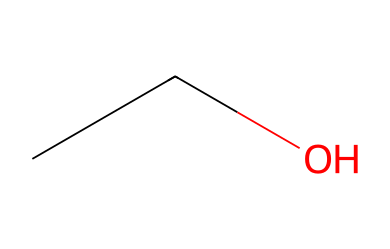How many carbon atoms are present in this molecule? The given SMILES representation "CCO" indicates two carbon atoms (C) since each "C" in the SMILES notation represents a carbon atom.
Answer: 2 What type of functional group does ethanol contain? The structure includes a hydroxyl group (-OH), which is characteristic of alcohols. In the given SMILES, the "O" following the two "C" indicates the presence of this functional group.
Answer: alcohol How many hydrogen atoms are associated with this molecule? In the SMILES "CCO", there are two carbon atoms each connected to a hydroxyl group, leading to a total of six hydrogen atoms when considering the valences of carbon and oxygen. Ethanol follows the formula C2H6O.
Answer: 6 Is this chemical polar or nonpolar? Ethanol contains a hydroxyl (-OH) group, making it polar due to the difference in electronegativity between oxygen and hydrogen, which creates a dipole moment.
Answer: polar What is the molecular weight of ethanol? Ethanol (C2H6O) consists of 2 carbon atoms (12.01 g/mol each), 6 hydrogen atoms (1.01 g/mol each), and 1 oxygen atom (16.00 g/mol), giving a total molecular weight of approximately 46.07 g/mol when calculated.
Answer: 46.07 Does this compound have hydrogen bonding capabilities? The presence of the -OH group in ethanol allows for hydrogen bonding between ethanol molecules, as this functional group can interact with other polar molecules or itself, leading to significant intermolecular attractions.
Answer: yes 